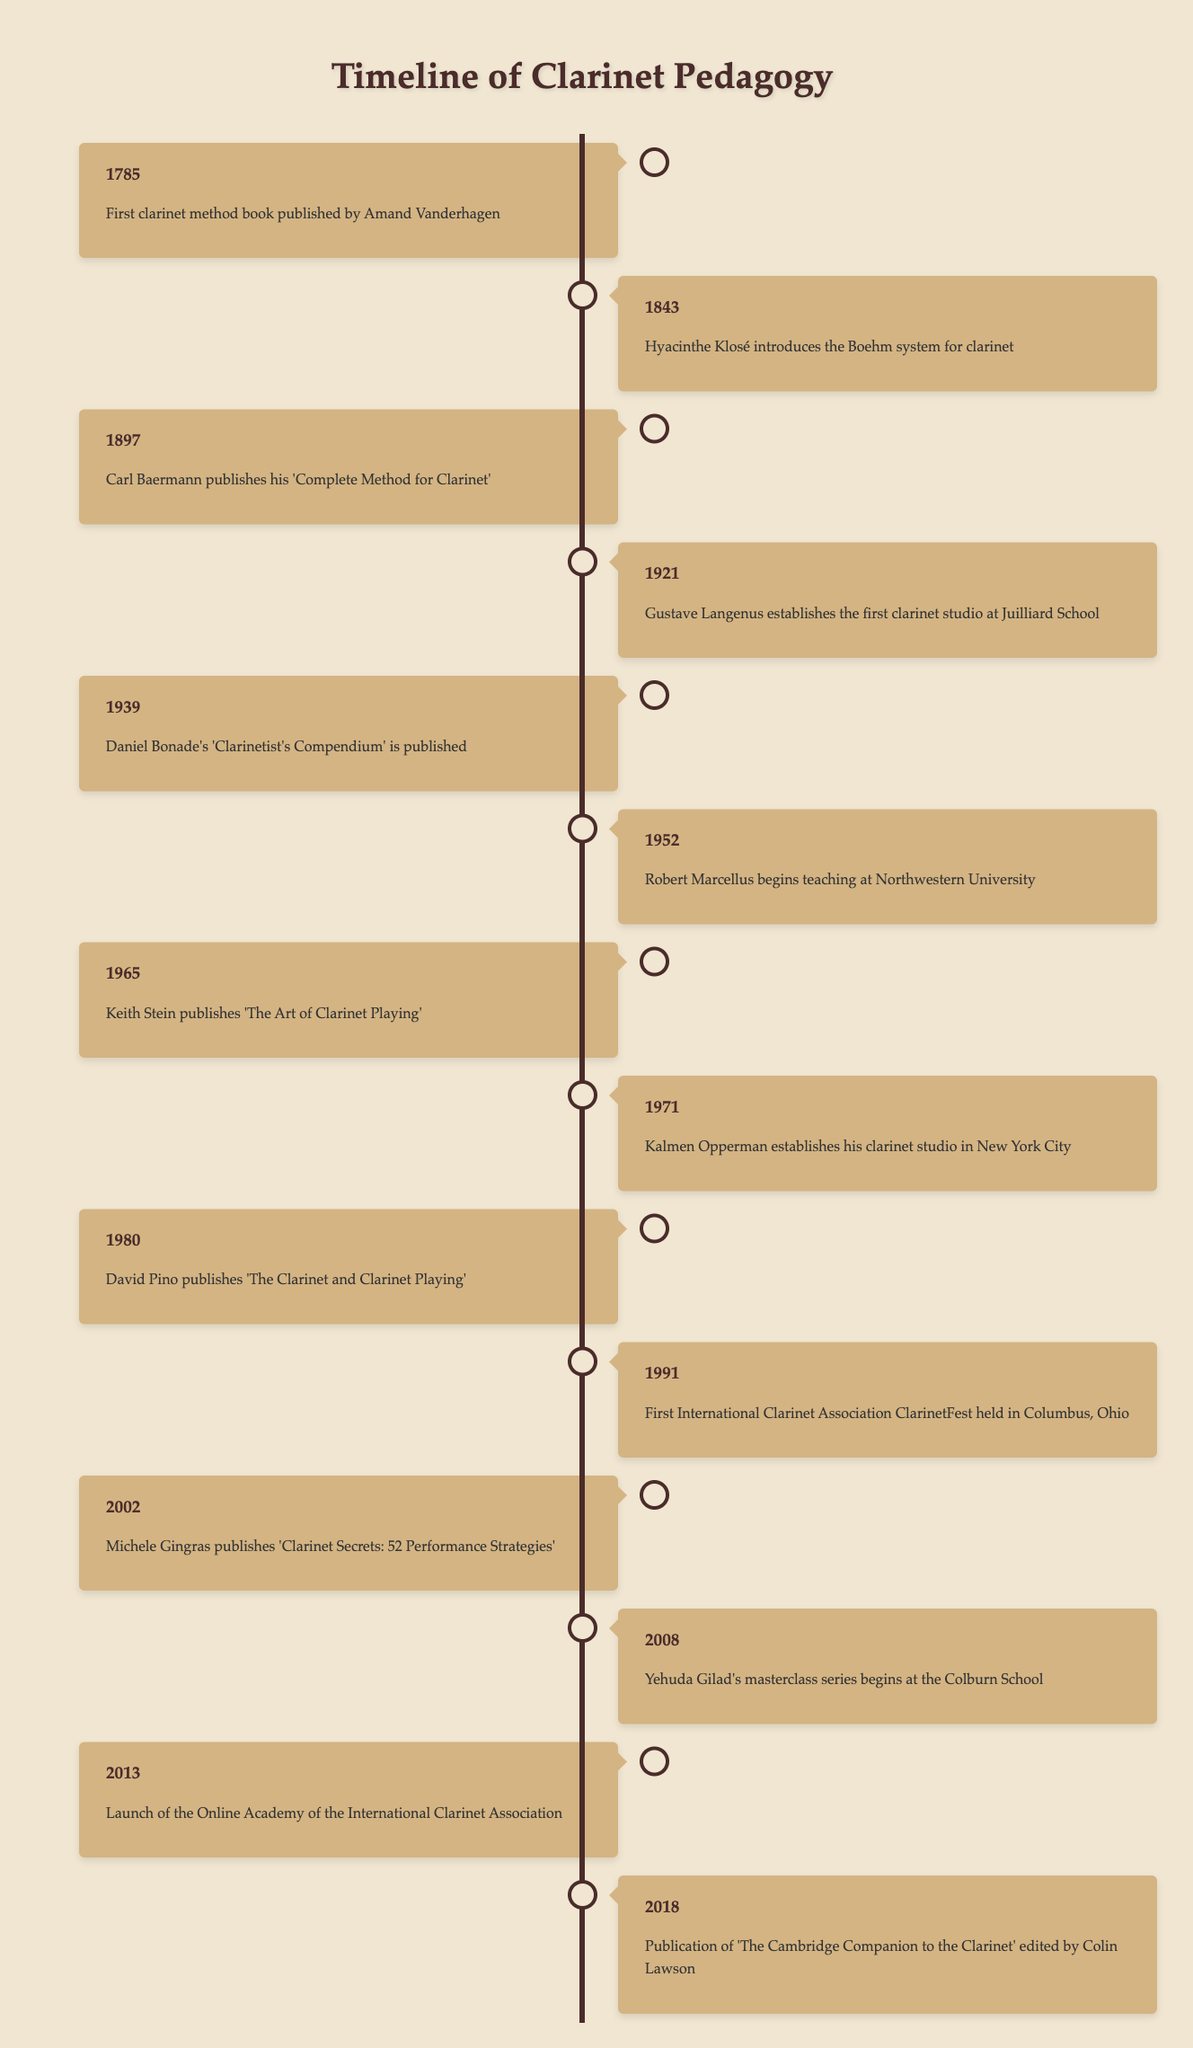What was the first significant event in clarinet pedagogy? The first significant event in clarinet pedagogy listed in the table is the publication of the first clarinet method book by Amand Vanderhagen in 1785.
Answer: 1785: First clarinet method book published by Amand Vanderhagen Who published 'The Art of Clarinet Playing' and in what year? 'The Art of Clarinet Playing' was published by Keith Stein in 1965 as stated in the table.
Answer: Keith Stein, 1965 How many years passed between the introduction of the Boehm system and the publication of 'Clarinet Secrets: 52 Performance Strategies'? The Boehm system was introduced in 1843 and 'Clarinet Secrets: 52 Performance Strategies' was published in 2002. The difference in years is 2002 - 1843 = 159 years.
Answer: 159 years Is it true that the first International Clarinet Association ClarinetFest was held before 2000? The table indicates that the first International Clarinet Association ClarinetFest was held in 1991, which is indeed before 2000.
Answer: Yes Which two events happened in the 2000s and what were they? Two events in the 2000s include Michele Gingras publishing 'Clarinet Secrets: 52 Performance Strategies' in 2002 and Yehuda Gilad's masterclass series beginning at the Colburn School in 2008.
Answer: 2002: Michele Gingras publishes 'Clarinet Secrets: 52 Performance Strategies', 2008: Yehuda Gilad's masterclass series begins at the Colburn School 